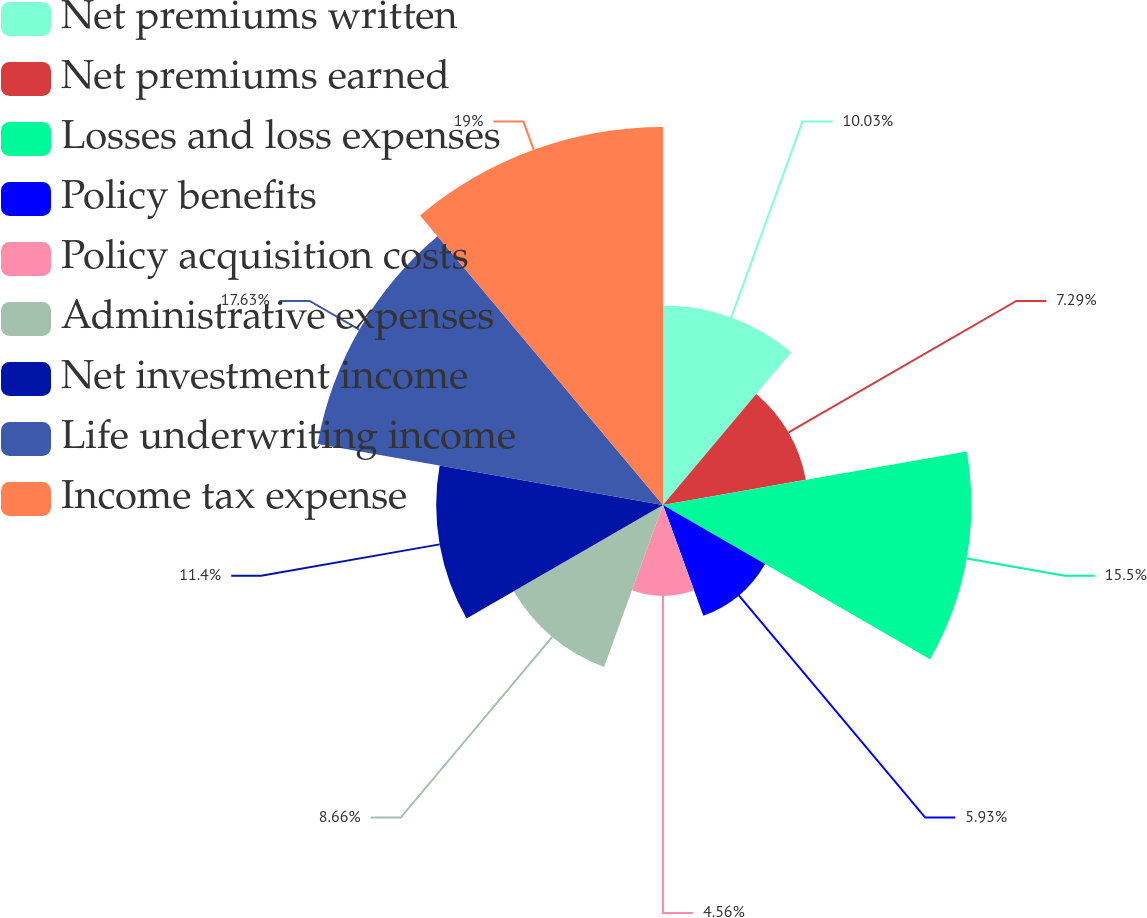Convert chart to OTSL. <chart><loc_0><loc_0><loc_500><loc_500><pie_chart><fcel>Net premiums written<fcel>Net premiums earned<fcel>Losses and loss expenses<fcel>Policy benefits<fcel>Policy acquisition costs<fcel>Administrative expenses<fcel>Net investment income<fcel>Life underwriting income<fcel>Income tax expense<nl><fcel>10.03%<fcel>7.29%<fcel>15.5%<fcel>5.93%<fcel>4.56%<fcel>8.66%<fcel>11.4%<fcel>17.63%<fcel>19.0%<nl></chart> 